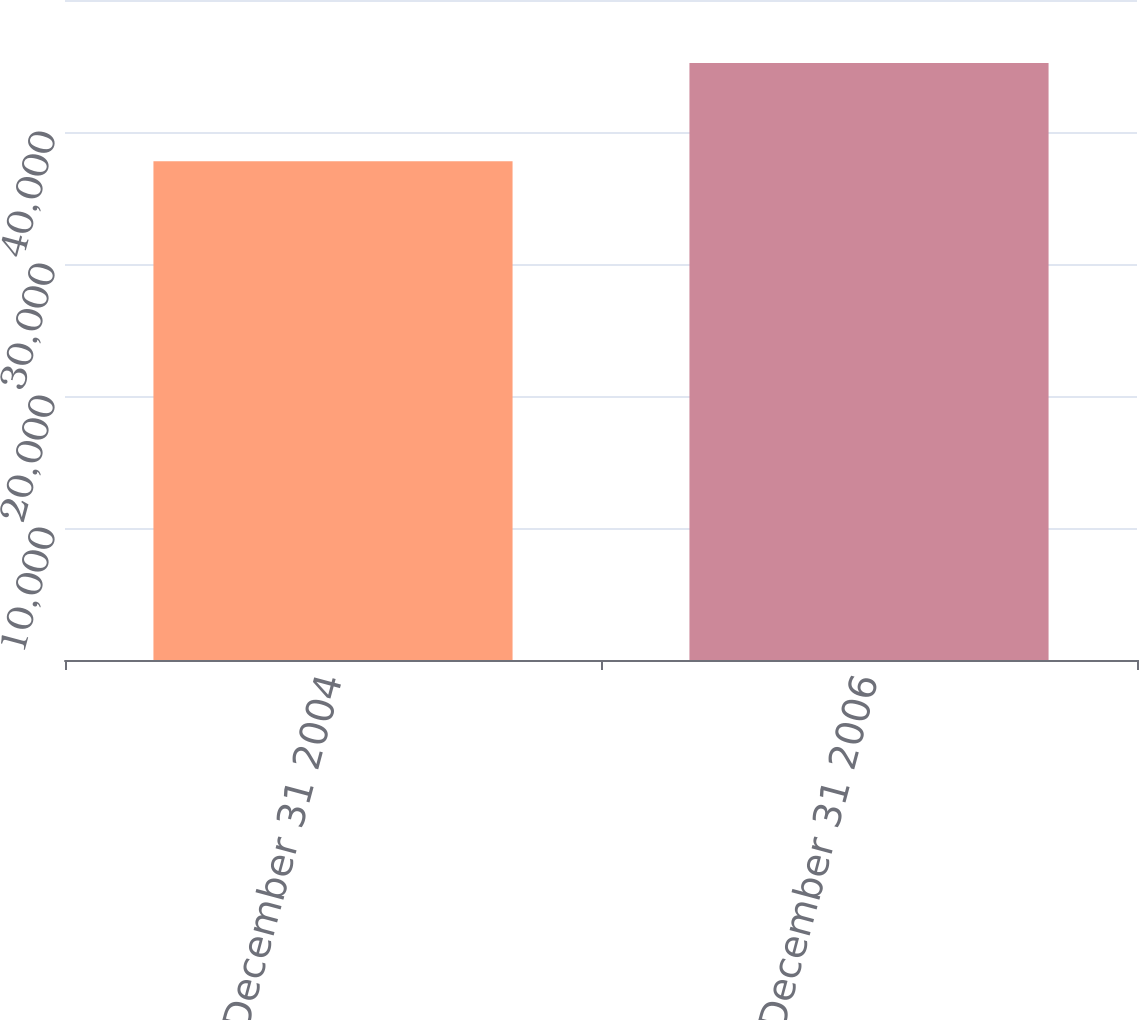Convert chart to OTSL. <chart><loc_0><loc_0><loc_500><loc_500><bar_chart><fcel>Balance December 31 2004<fcel>Balance December 31 2006<nl><fcel>37781<fcel>45225<nl></chart> 